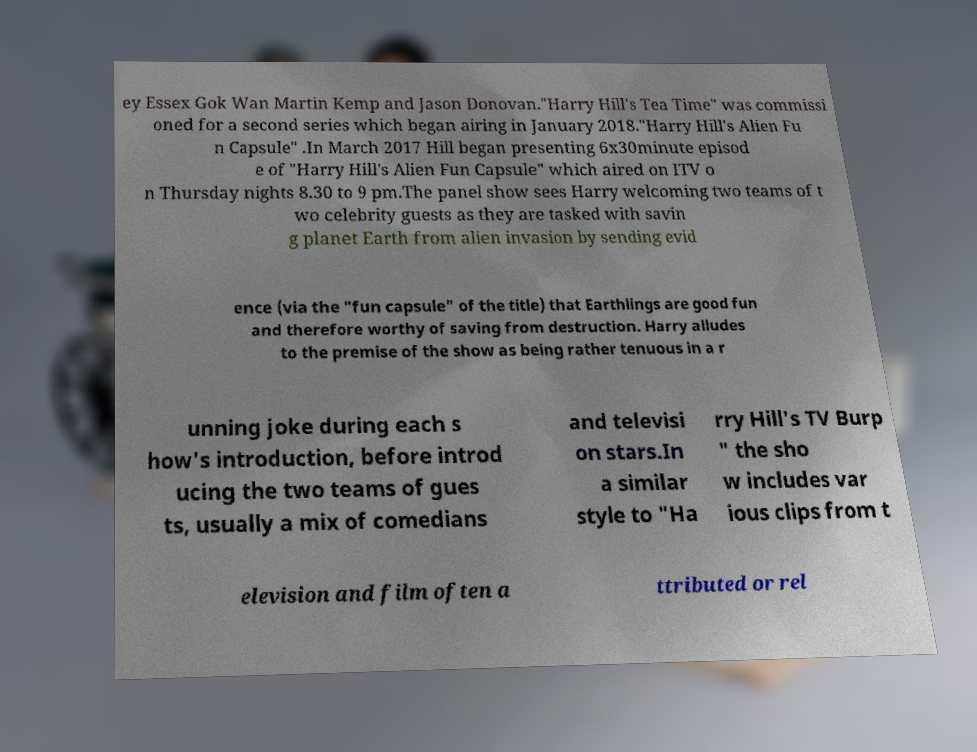Please identify and transcribe the text found in this image. ey Essex Gok Wan Martin Kemp and Jason Donovan."Harry Hill's Tea Time" was commissi oned for a second series which began airing in January 2018."Harry Hill's Alien Fu n Capsule" .In March 2017 Hill began presenting 6x30minute episod e of "Harry Hill's Alien Fun Capsule" which aired on ITV o n Thursday nights 8.30 to 9 pm.The panel show sees Harry welcoming two teams of t wo celebrity guests as they are tasked with savin g planet Earth from alien invasion by sending evid ence (via the "fun capsule" of the title) that Earthlings are good fun and therefore worthy of saving from destruction. Harry alludes to the premise of the show as being rather tenuous in a r unning joke during each s how's introduction, before introd ucing the two teams of gues ts, usually a mix of comedians and televisi on stars.In a similar style to "Ha rry Hill's TV Burp " the sho w includes var ious clips from t elevision and film often a ttributed or rel 